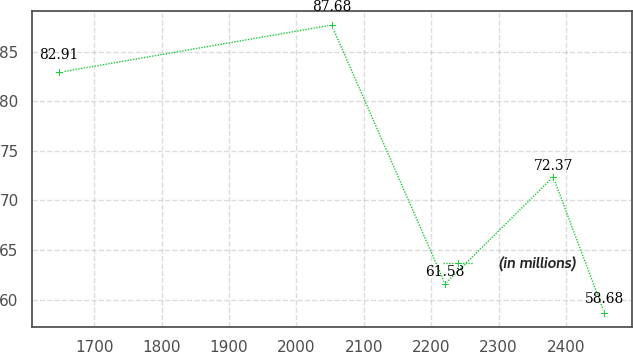<chart> <loc_0><loc_0><loc_500><loc_500><line_chart><ecel><fcel>(in millions)<nl><fcel>1647.61<fcel>82.91<nl><fcel>2052.17<fcel>87.68<nl><fcel>2220.61<fcel>61.58<nl><fcel>2380.95<fcel>72.37<nl><fcel>2456.8<fcel>58.68<nl></chart> 